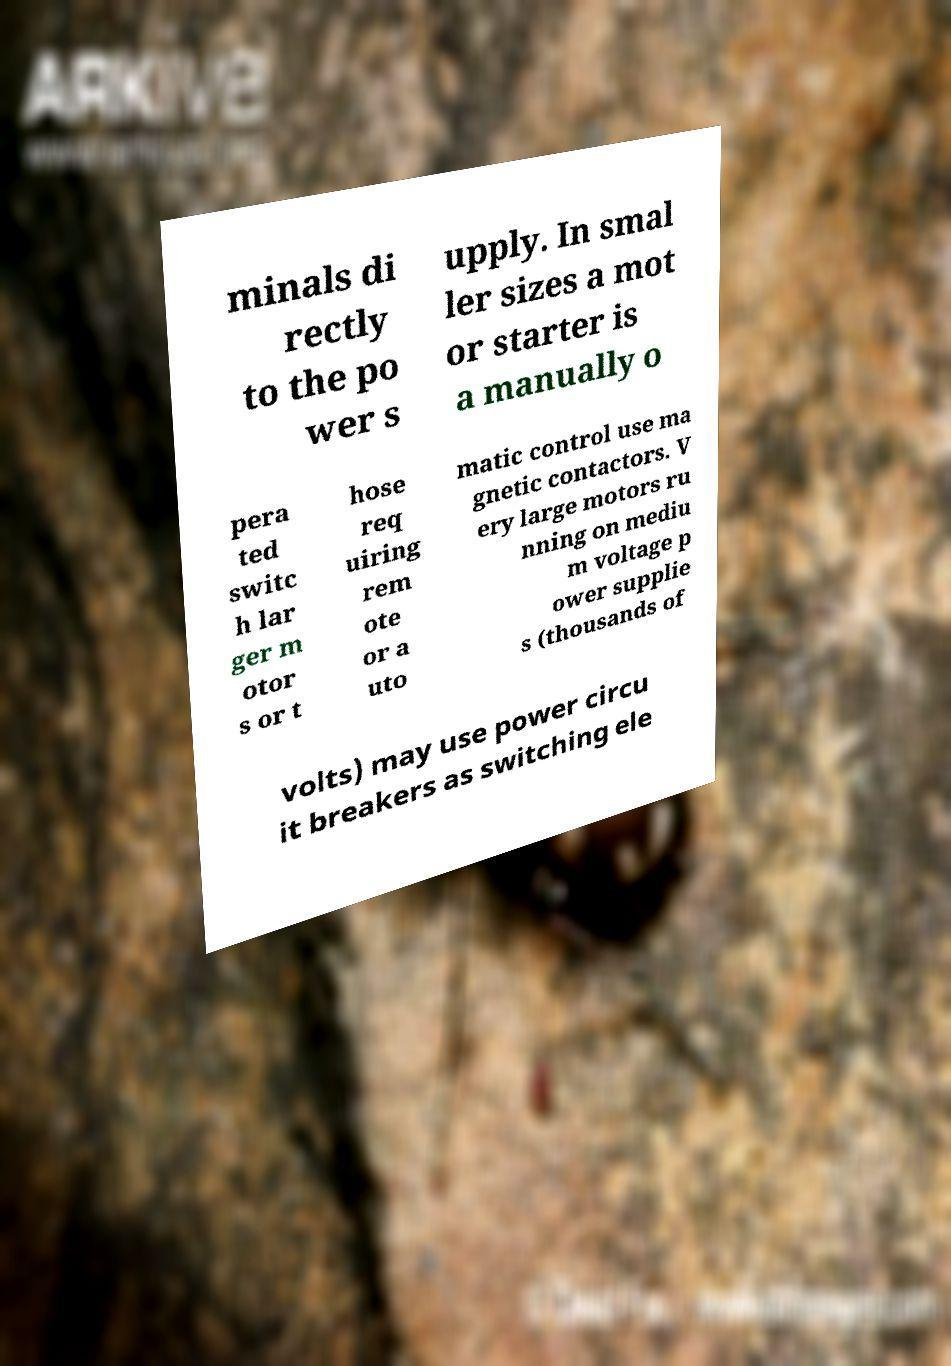Could you extract and type out the text from this image? minals di rectly to the po wer s upply. In smal ler sizes a mot or starter is a manually o pera ted switc h lar ger m otor s or t hose req uiring rem ote or a uto matic control use ma gnetic contactors. V ery large motors ru nning on mediu m voltage p ower supplie s (thousands of volts) may use power circu it breakers as switching ele 